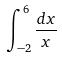Convert formula to latex. <formula><loc_0><loc_0><loc_500><loc_500>\int _ { - 2 } ^ { 6 } \frac { d x } { x }</formula> 